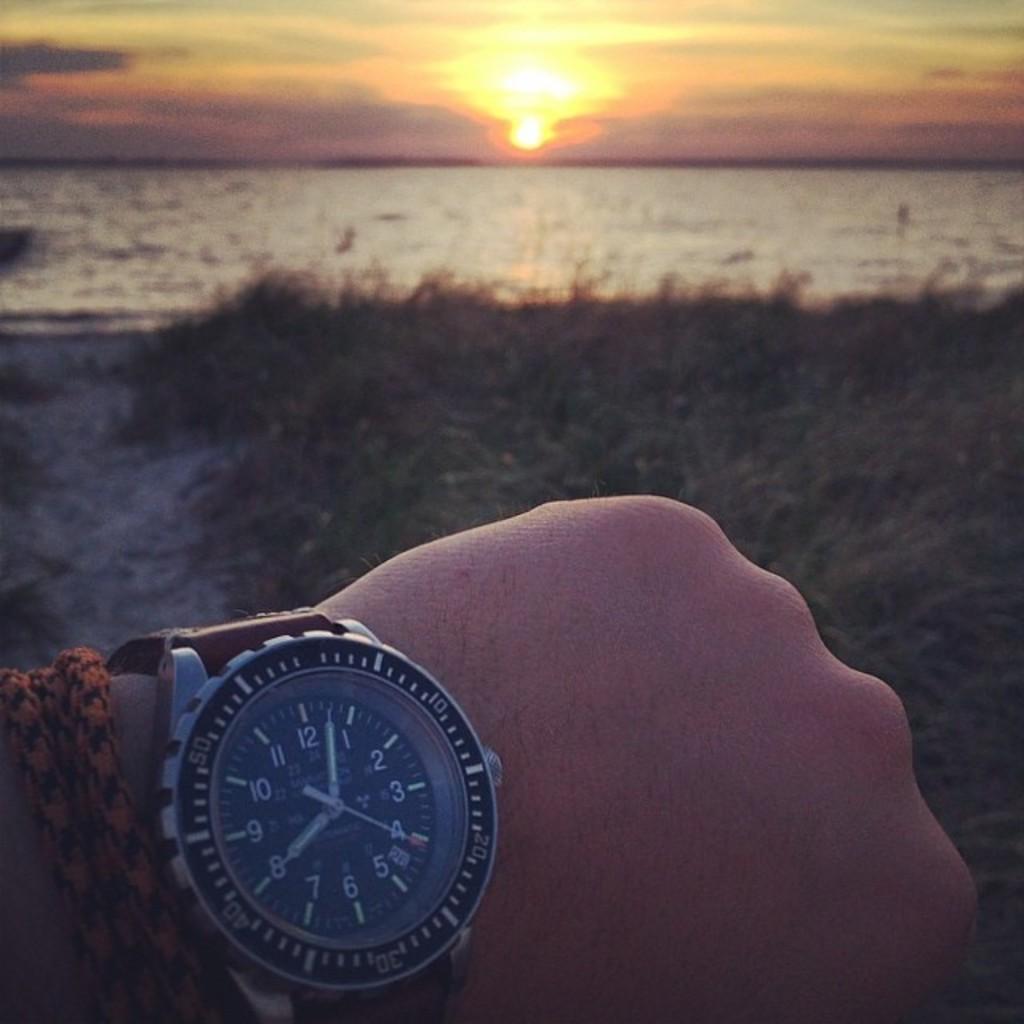Can you describe this image briefly? In this picture there is a hand of a person having a wrist watch and a thread attached to his hand and there is a greenery ground in front of him and there is water and sun in the background. 